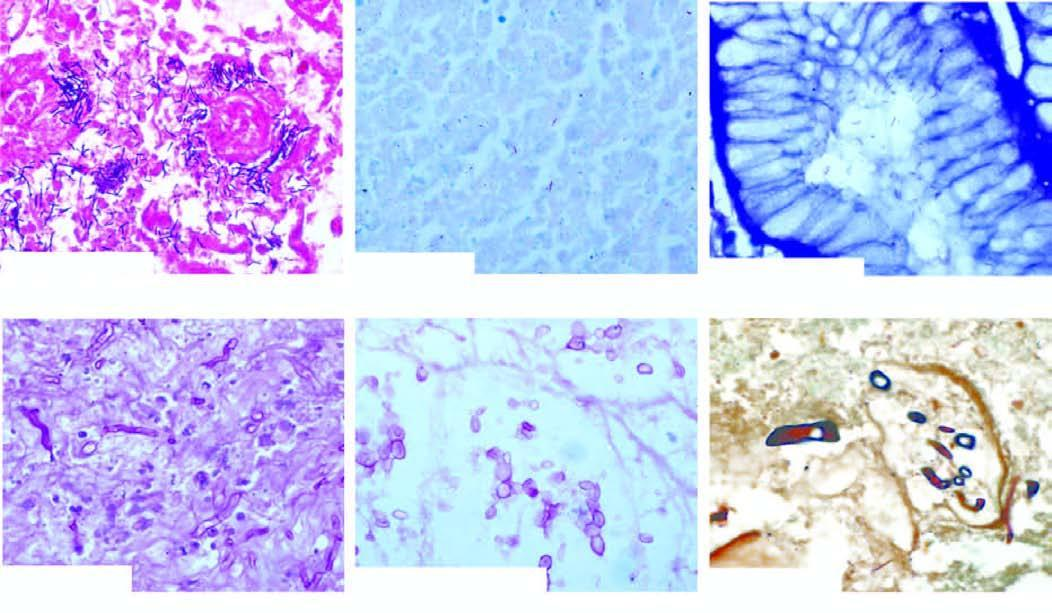s endothelial injury used for demonstration of microbes?
Answer the question using a single word or phrase. No 